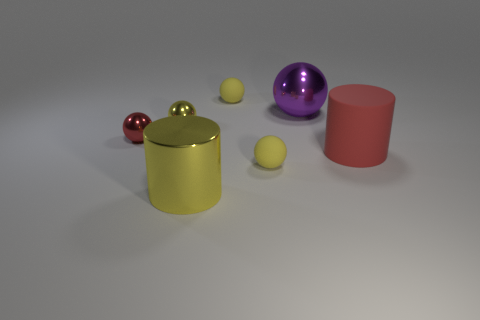The big thing that is behind the yellow shiny thing that is behind the large yellow object is what shape?
Offer a terse response. Sphere. There is a big object that is right of the big purple metallic sphere; is its color the same as the tiny metal object that is left of the yellow metallic ball?
Keep it short and to the point. Yes. Are there any other things that are the same color as the large sphere?
Your answer should be compact. No. What is the color of the large shiny cylinder?
Offer a very short reply. Yellow. Is there a gray shiny cube?
Your answer should be compact. No. Are there any big matte things on the left side of the red metallic object?
Your response must be concise. No. There is a purple object that is the same shape as the small red shiny thing; what is its material?
Offer a terse response. Metal. What number of other objects are the same shape as the large matte object?
Your answer should be very brief. 1. There is a small yellow rubber sphere that is in front of the sphere that is behind the purple shiny object; how many metallic balls are to the left of it?
Offer a terse response. 2. What number of yellow things have the same shape as the big purple thing?
Make the answer very short. 3. 